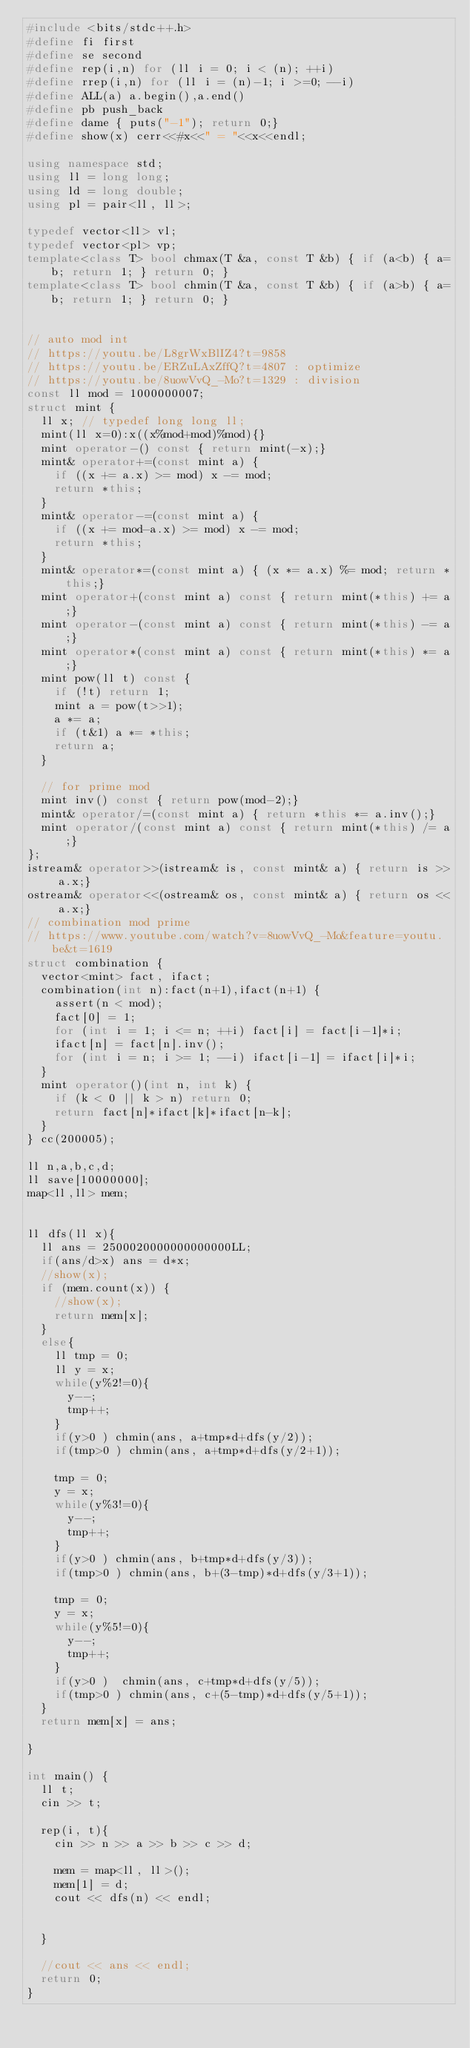Convert code to text. <code><loc_0><loc_0><loc_500><loc_500><_C++_>#include <bits/stdc++.h>
#define fi first
#define se second
#define rep(i,n) for (ll i = 0; i < (n); ++i)
#define rrep(i,n) for (ll i = (n)-1; i >=0; --i)
#define ALL(a) a.begin(),a.end()
#define pb push_back
#define dame { puts("-1"); return 0;}
#define show(x) cerr<<#x<<" = "<<x<<endl;

using namespace std;
using ll = long long;
using ld = long double;
using pl = pair<ll, ll>;

typedef vector<ll> vl;
typedef vector<pl> vp;
template<class T> bool chmax(T &a, const T &b) { if (a<b) { a=b; return 1; } return 0; }
template<class T> bool chmin(T &a, const T &b) { if (a>b) { a=b; return 1; } return 0; }


// auto mod int
// https://youtu.be/L8grWxBlIZ4?t=9858
// https://youtu.be/ERZuLAxZffQ?t=4807 : optimize
// https://youtu.be/8uowVvQ_-Mo?t=1329 : division
const ll mod = 1000000007;
struct mint {
  ll x; // typedef long long ll;
  mint(ll x=0):x((x%mod+mod)%mod){}
  mint operator-() const { return mint(-x);}
  mint& operator+=(const mint a) {
    if ((x += a.x) >= mod) x -= mod;
    return *this;
  }
  mint& operator-=(const mint a) {
    if ((x += mod-a.x) >= mod) x -= mod;
    return *this;
  }
  mint& operator*=(const mint a) { (x *= a.x) %= mod; return *this;}
  mint operator+(const mint a) const { return mint(*this) += a;}
  mint operator-(const mint a) const { return mint(*this) -= a;}
  mint operator*(const mint a) const { return mint(*this) *= a;}
  mint pow(ll t) const {
    if (!t) return 1;
    mint a = pow(t>>1);
    a *= a;
    if (t&1) a *= *this;
    return a;
  }

  // for prime mod
  mint inv() const { return pow(mod-2);}
  mint& operator/=(const mint a) { return *this *= a.inv();}
  mint operator/(const mint a) const { return mint(*this) /= a;}
};
istream& operator>>(istream& is, const mint& a) { return is >> a.x;}
ostream& operator<<(ostream& os, const mint& a) { return os << a.x;}
// combination mod prime
// https://www.youtube.com/watch?v=8uowVvQ_-Mo&feature=youtu.be&t=1619
struct combination {
  vector<mint> fact, ifact;
  combination(int n):fact(n+1),ifact(n+1) {
    assert(n < mod);
    fact[0] = 1;
    for (int i = 1; i <= n; ++i) fact[i] = fact[i-1]*i;
    ifact[n] = fact[n].inv();
    for (int i = n; i >= 1; --i) ifact[i-1] = ifact[i]*i;
  }
  mint operator()(int n, int k) {
    if (k < 0 || k > n) return 0;
    return fact[n]*ifact[k]*ifact[n-k];
  }
} cc(200005);

ll n,a,b,c,d;
ll save[10000000];
map<ll,ll> mem;


ll dfs(ll x){
  ll ans = 2500020000000000000LL;
  if(ans/d>x) ans = d*x;
  //show(x);
  if (mem.count(x)) {
    //show(x);
    return mem[x];
  }
  else{
    ll tmp = 0;
    ll y = x;
    while(y%2!=0){
      y--;
      tmp++;
    }
    if(y>0 ) chmin(ans, a+tmp*d+dfs(y/2));
    if(tmp>0 ) chmin(ans, a+tmp*d+dfs(y/2+1));

    tmp = 0;
    y = x;
    while(y%3!=0){
      y--;
      tmp++;
    }
    if(y>0 ) chmin(ans, b+tmp*d+dfs(y/3));
    if(tmp>0 ) chmin(ans, b+(3-tmp)*d+dfs(y/3+1));

    tmp = 0;
    y = x;
    while(y%5!=0){
      y--;
      tmp++;
    }
    if(y>0 )  chmin(ans, c+tmp*d+dfs(y/5));
    if(tmp>0 ) chmin(ans, c+(5-tmp)*d+dfs(y/5+1));
  }
  return mem[x] = ans;

}

int main() {
  ll t;
  cin >> t;

  rep(i, t){
    cin >> n >> a >> b >> c >> d;
    
    mem = map<ll, ll>();
    mem[1] = d;
    cout << dfs(n) << endl;
    
    
  }

  //cout << ans << endl;
  return 0;
}
</code> 